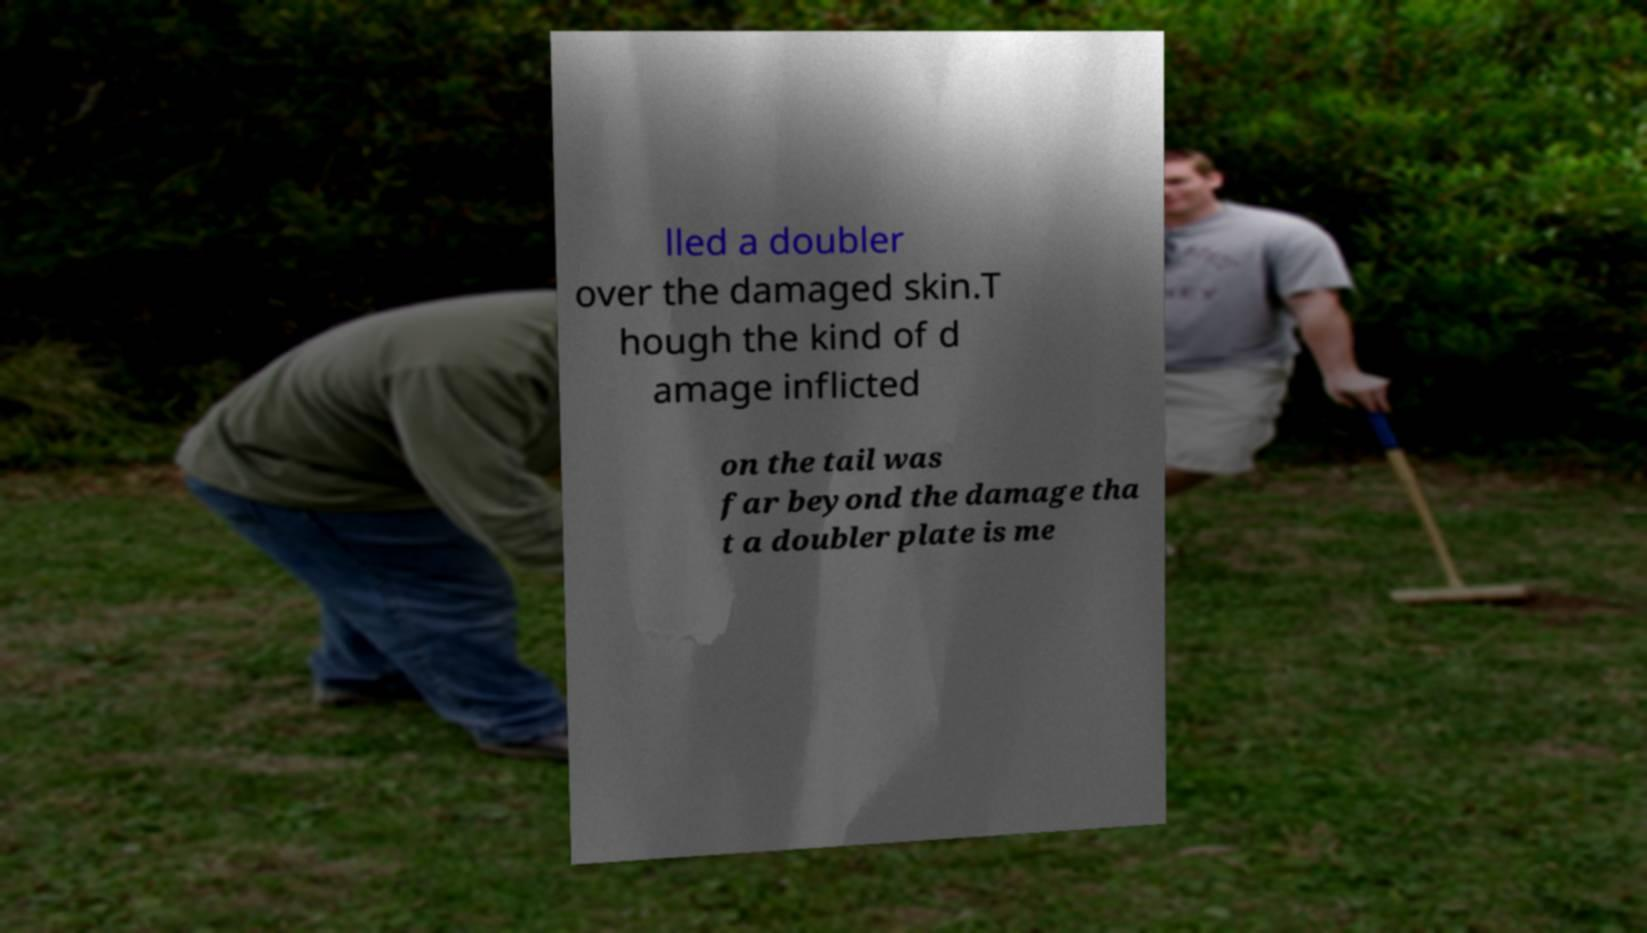Could you extract and type out the text from this image? lled a doubler over the damaged skin.T hough the kind of d amage inflicted on the tail was far beyond the damage tha t a doubler plate is me 